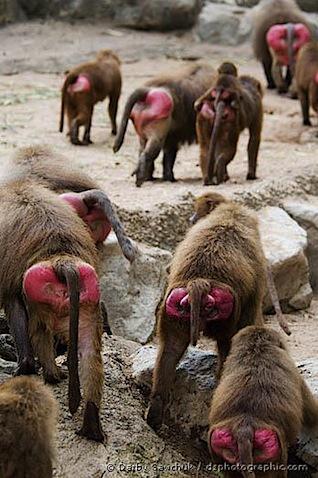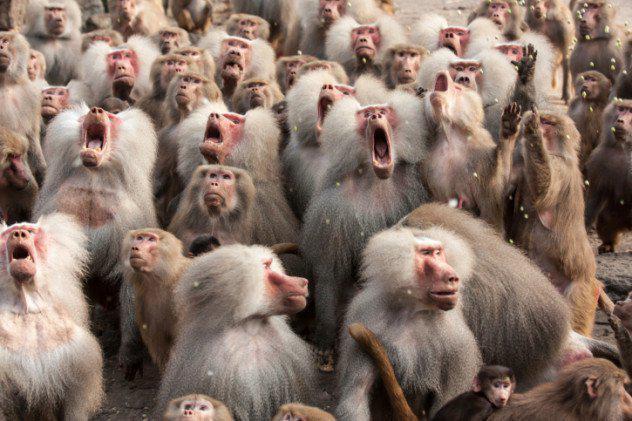The first image is the image on the left, the second image is the image on the right. Analyze the images presented: Is the assertion "A small amount of sky can be seen in the background of the image on the right" valid? Answer yes or no. No. The first image is the image on the left, the second image is the image on the right. Evaluate the accuracy of this statement regarding the images: "Bulbous pink rear ends of multiple baboons are visible in one image.". Is it true? Answer yes or no. Yes. 